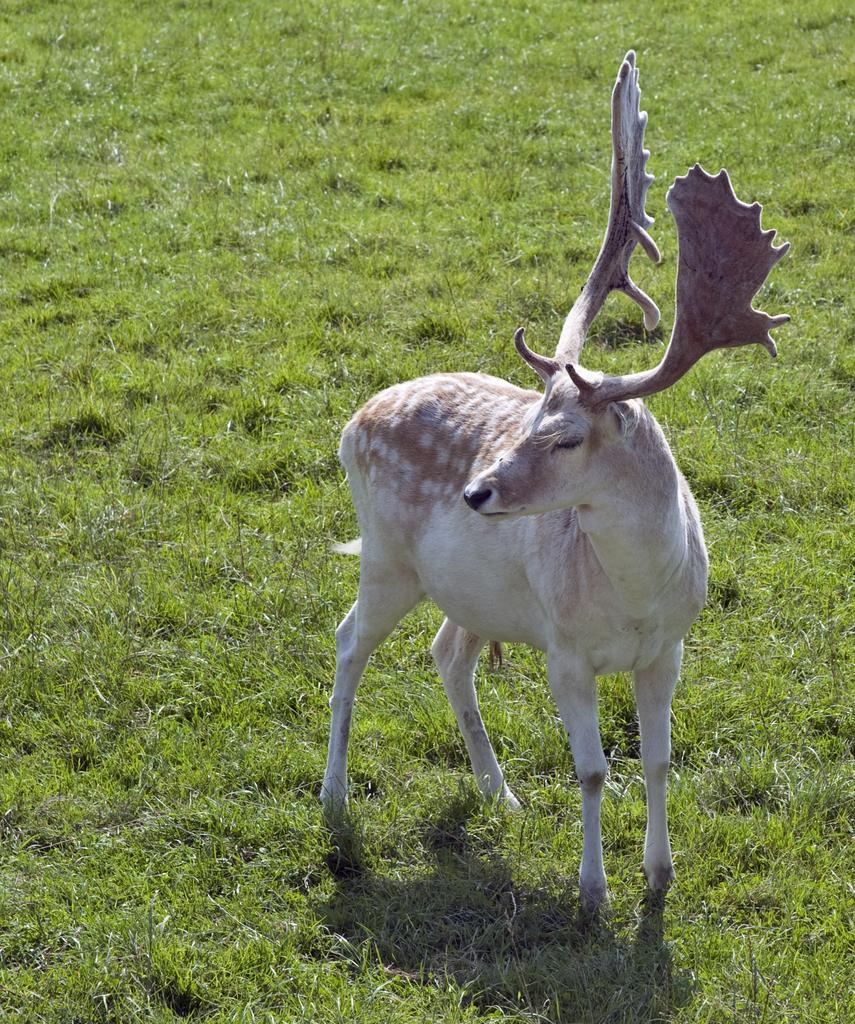What animal can be seen in the picture? There is a deer in the picture. What type of vegetation is visible in the picture? There is grass visible in the picture. How many plants are in the basket in the image? There is no basket or plants present in the image. 